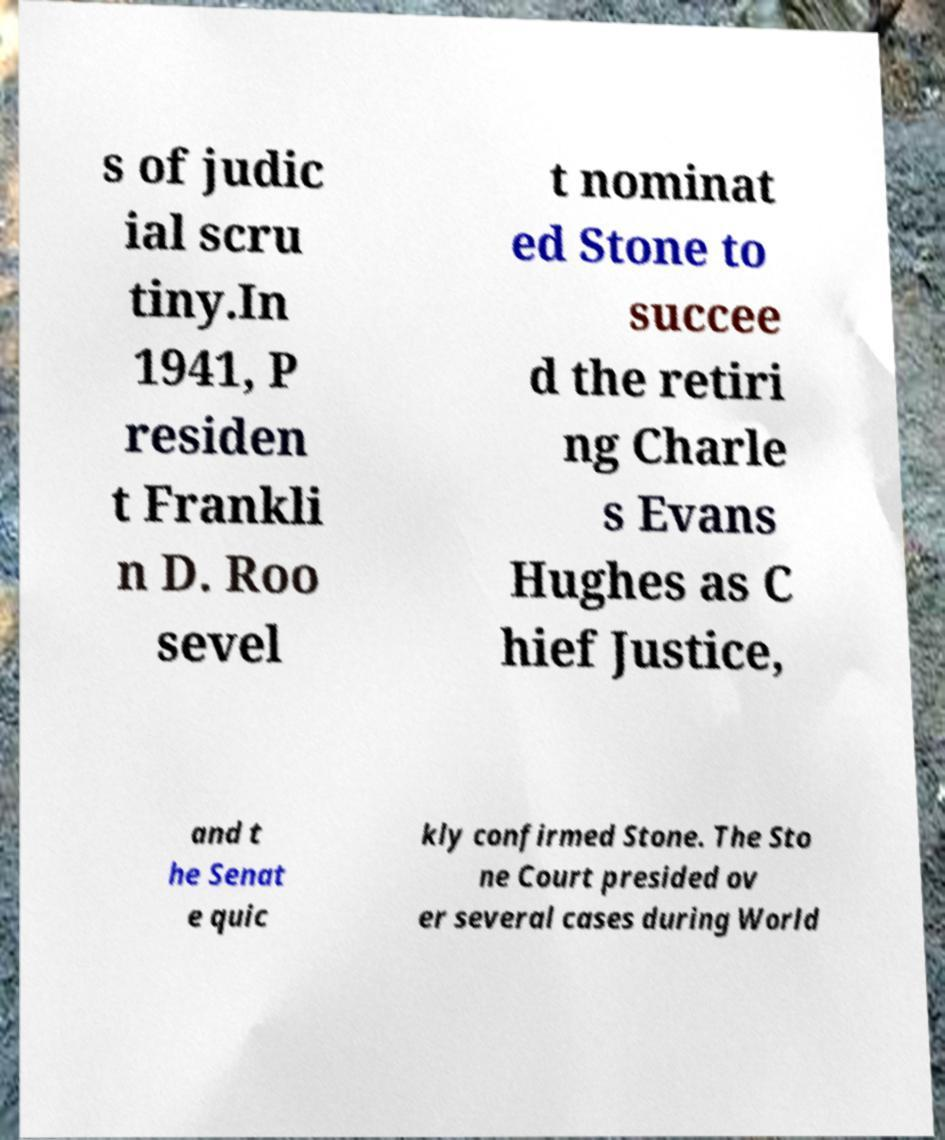Please identify and transcribe the text found in this image. s of judic ial scru tiny.In 1941, P residen t Frankli n D. Roo sevel t nominat ed Stone to succee d the retiri ng Charle s Evans Hughes as C hief Justice, and t he Senat e quic kly confirmed Stone. The Sto ne Court presided ov er several cases during World 